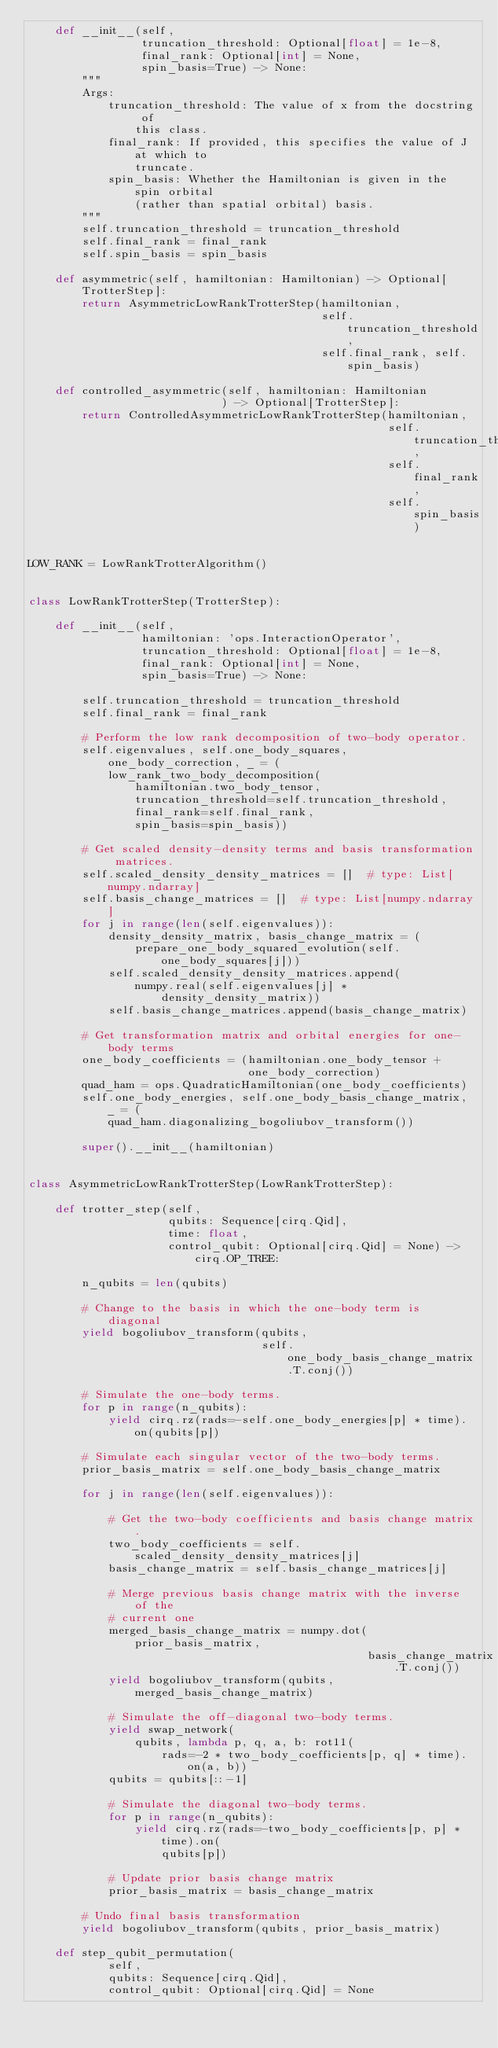Convert code to text. <code><loc_0><loc_0><loc_500><loc_500><_Python_>    def __init__(self,
                 truncation_threshold: Optional[float] = 1e-8,
                 final_rank: Optional[int] = None,
                 spin_basis=True) -> None:
        """
        Args:
            truncation_threshold: The value of x from the docstring of
                this class.
            final_rank: If provided, this specifies the value of J at which to
                truncate.
            spin_basis: Whether the Hamiltonian is given in the spin orbital
                (rather than spatial orbital) basis.
        """
        self.truncation_threshold = truncation_threshold
        self.final_rank = final_rank
        self.spin_basis = spin_basis

    def asymmetric(self, hamiltonian: Hamiltonian) -> Optional[TrotterStep]:
        return AsymmetricLowRankTrotterStep(hamiltonian,
                                            self.truncation_threshold,
                                            self.final_rank, self.spin_basis)

    def controlled_asymmetric(self, hamiltonian: Hamiltonian
                             ) -> Optional[TrotterStep]:
        return ControlledAsymmetricLowRankTrotterStep(hamiltonian,
                                                      self.truncation_threshold,
                                                      self.final_rank,
                                                      self.spin_basis)


LOW_RANK = LowRankTrotterAlgorithm()


class LowRankTrotterStep(TrotterStep):

    def __init__(self,
                 hamiltonian: 'ops.InteractionOperator',
                 truncation_threshold: Optional[float] = 1e-8,
                 final_rank: Optional[int] = None,
                 spin_basis=True) -> None:

        self.truncation_threshold = truncation_threshold
        self.final_rank = final_rank

        # Perform the low rank decomposition of two-body operator.
        self.eigenvalues, self.one_body_squares, one_body_correction, _ = (
            low_rank_two_body_decomposition(
                hamiltonian.two_body_tensor,
                truncation_threshold=self.truncation_threshold,
                final_rank=self.final_rank,
                spin_basis=spin_basis))

        # Get scaled density-density terms and basis transformation matrices.
        self.scaled_density_density_matrices = []  # type: List[numpy.ndarray]
        self.basis_change_matrices = []  # type: List[numpy.ndarray]
        for j in range(len(self.eigenvalues)):
            density_density_matrix, basis_change_matrix = (
                prepare_one_body_squared_evolution(self.one_body_squares[j]))
            self.scaled_density_density_matrices.append(
                numpy.real(self.eigenvalues[j] * density_density_matrix))
            self.basis_change_matrices.append(basis_change_matrix)

        # Get transformation matrix and orbital energies for one-body terms
        one_body_coefficients = (hamiltonian.one_body_tensor +
                                 one_body_correction)
        quad_ham = ops.QuadraticHamiltonian(one_body_coefficients)
        self.one_body_energies, self.one_body_basis_change_matrix, _ = (
            quad_ham.diagonalizing_bogoliubov_transform())

        super().__init__(hamiltonian)


class AsymmetricLowRankTrotterStep(LowRankTrotterStep):

    def trotter_step(self,
                     qubits: Sequence[cirq.Qid],
                     time: float,
                     control_qubit: Optional[cirq.Qid] = None) -> cirq.OP_TREE:

        n_qubits = len(qubits)

        # Change to the basis in which the one-body term is diagonal
        yield bogoliubov_transform(qubits,
                                   self.one_body_basis_change_matrix.T.conj())

        # Simulate the one-body terms.
        for p in range(n_qubits):
            yield cirq.rz(rads=-self.one_body_energies[p] * time).on(qubits[p])

        # Simulate each singular vector of the two-body terms.
        prior_basis_matrix = self.one_body_basis_change_matrix

        for j in range(len(self.eigenvalues)):

            # Get the two-body coefficients and basis change matrix.
            two_body_coefficients = self.scaled_density_density_matrices[j]
            basis_change_matrix = self.basis_change_matrices[j]

            # Merge previous basis change matrix with the inverse of the
            # current one
            merged_basis_change_matrix = numpy.dot(prior_basis_matrix,
                                                   basis_change_matrix.T.conj())
            yield bogoliubov_transform(qubits, merged_basis_change_matrix)

            # Simulate the off-diagonal two-body terms.
            yield swap_network(
                qubits, lambda p, q, a, b: rot11(
                    rads=-2 * two_body_coefficients[p, q] * time).on(a, b))
            qubits = qubits[::-1]

            # Simulate the diagonal two-body terms.
            for p in range(n_qubits):
                yield cirq.rz(rads=-two_body_coefficients[p, p] * time).on(
                    qubits[p])

            # Update prior basis change matrix
            prior_basis_matrix = basis_change_matrix

        # Undo final basis transformation
        yield bogoliubov_transform(qubits, prior_basis_matrix)

    def step_qubit_permutation(
            self,
            qubits: Sequence[cirq.Qid],
            control_qubit: Optional[cirq.Qid] = None</code> 